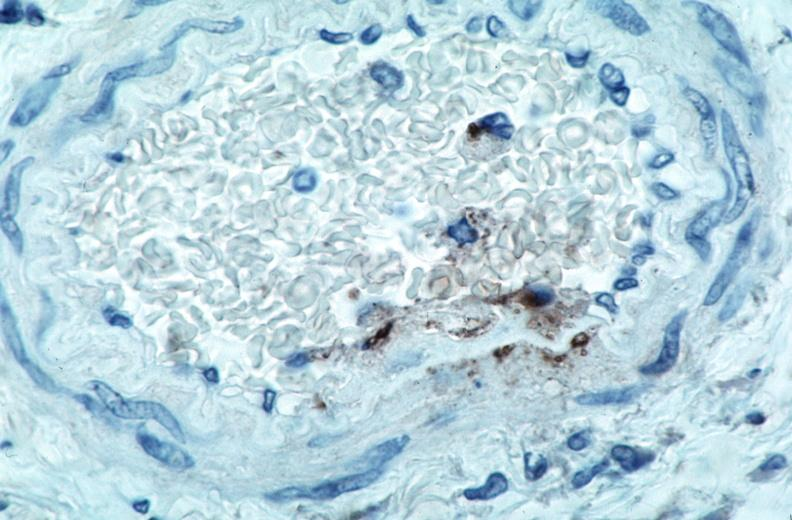s cranial artery spotted fever, immunoperoxidase staining vessels for rickettsia rickettsii?
Answer the question using a single word or phrase. No 